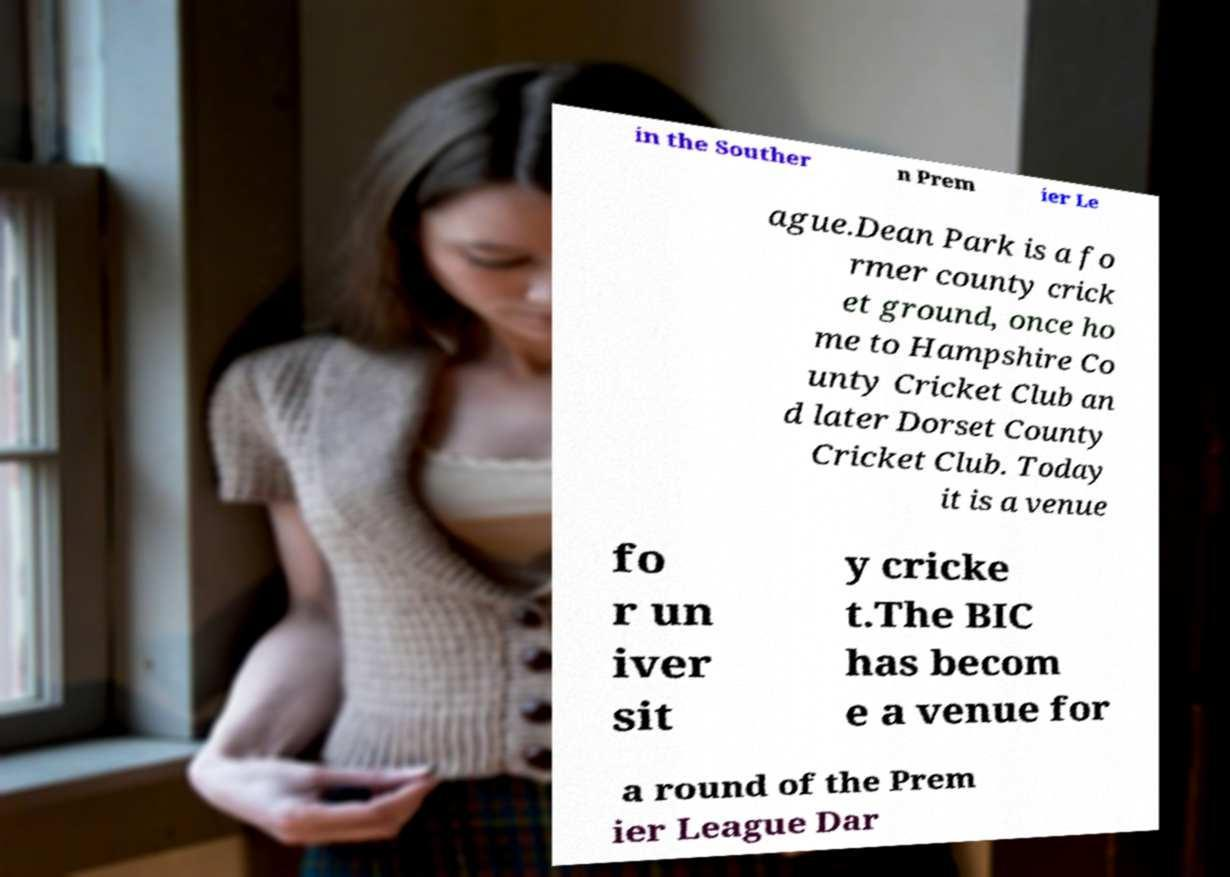For documentation purposes, I need the text within this image transcribed. Could you provide that? in the Souther n Prem ier Le ague.Dean Park is a fo rmer county crick et ground, once ho me to Hampshire Co unty Cricket Club an d later Dorset County Cricket Club. Today it is a venue fo r un iver sit y cricke t.The BIC has becom e a venue for a round of the Prem ier League Dar 